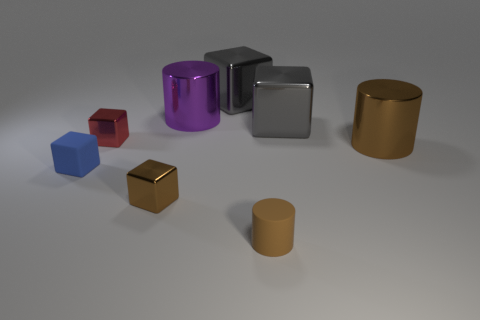What materials do the objects in the image seem to be made of? The objects in the image have reflective surfaces that suggest they are made of metal, potentially a mix of steel and colored metals for the vibrantly hued ones.  Are there any patterns or symmetries in the arrangement of these objects? There's no discernible pattern or symmetry in their arrangement. The objects are scattered randomly across the surface. 